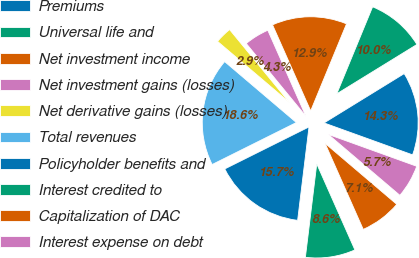<chart> <loc_0><loc_0><loc_500><loc_500><pie_chart><fcel>Premiums<fcel>Universal life and<fcel>Net investment income<fcel>Net investment gains (losses)<fcel>Net derivative gains (losses)<fcel>Total revenues<fcel>Policyholder benefits and<fcel>Interest credited to<fcel>Capitalization of DAC<fcel>Interest expense on debt<nl><fcel>14.29%<fcel>10.0%<fcel>12.86%<fcel>4.29%<fcel>2.86%<fcel>18.57%<fcel>15.71%<fcel>8.57%<fcel>7.14%<fcel>5.71%<nl></chart> 